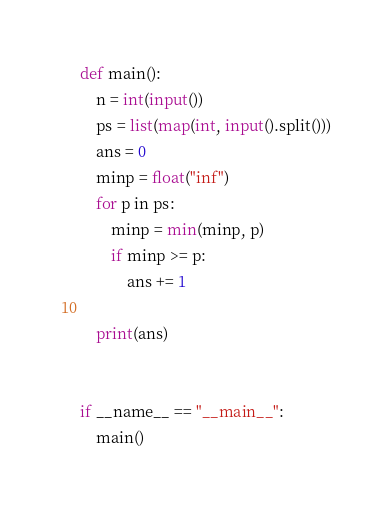<code> <loc_0><loc_0><loc_500><loc_500><_Python_>def main():
    n = int(input())
    ps = list(map(int, input().split()))
    ans = 0
    minp = float("inf")
    for p in ps:
        minp = min(minp, p)
        if minp >= p:
            ans += 1

    print(ans)


if __name__ == "__main__":
    main()
</code> 